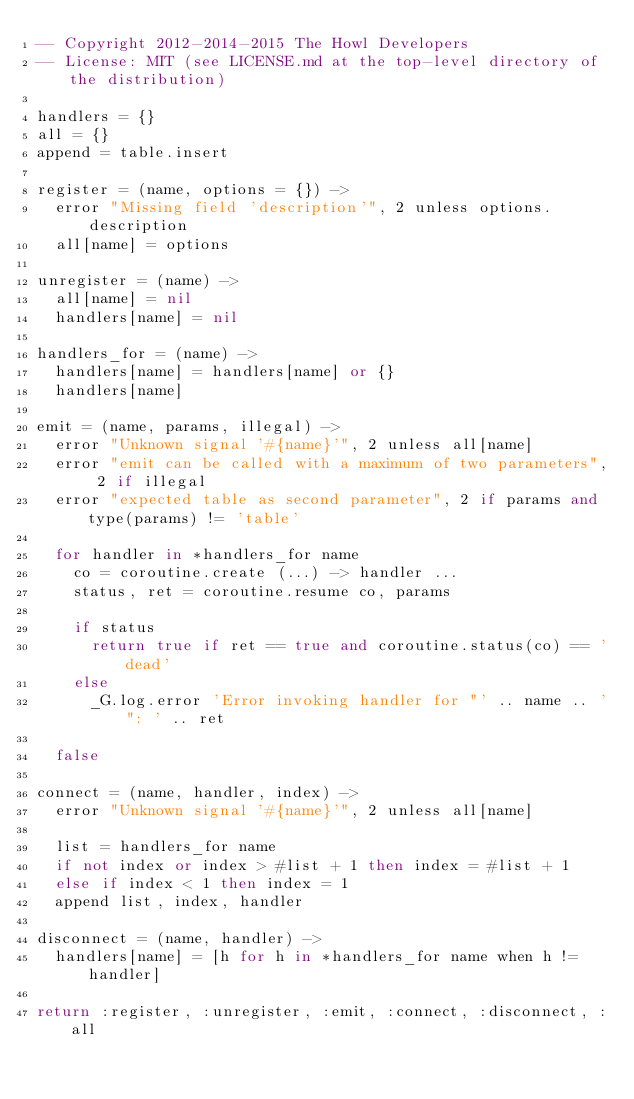Convert code to text. <code><loc_0><loc_0><loc_500><loc_500><_MoonScript_>-- Copyright 2012-2014-2015 The Howl Developers
-- License: MIT (see LICENSE.md at the top-level directory of the distribution)

handlers = {}
all = {}
append = table.insert

register = (name, options = {}) ->
  error "Missing field 'description'", 2 unless options.description
  all[name] = options

unregister = (name) ->
  all[name] = nil
  handlers[name] = nil

handlers_for = (name) ->
  handlers[name] = handlers[name] or {}
  handlers[name]

emit = (name, params, illegal) ->
  error "Unknown signal '#{name}'", 2 unless all[name]
  error "emit can be called with a maximum of two parameters", 2 if illegal
  error "expected table as second parameter", 2 if params and type(params) != 'table'

  for handler in *handlers_for name
    co = coroutine.create (...) -> handler ...
    status, ret = coroutine.resume co, params

    if status
      return true if ret == true and coroutine.status(co) == 'dead'
    else
      _G.log.error 'Error invoking handler for "' .. name .. '": ' .. ret

  false

connect = (name, handler, index) ->
  error "Unknown signal '#{name}'", 2 unless all[name]

  list = handlers_for name
  if not index or index > #list + 1 then index = #list + 1
  else if index < 1 then index = 1
  append list, index, handler

disconnect = (name, handler) ->
  handlers[name] = [h for h in *handlers_for name when h != handler]

return :register, :unregister, :emit, :connect, :disconnect, :all
</code> 